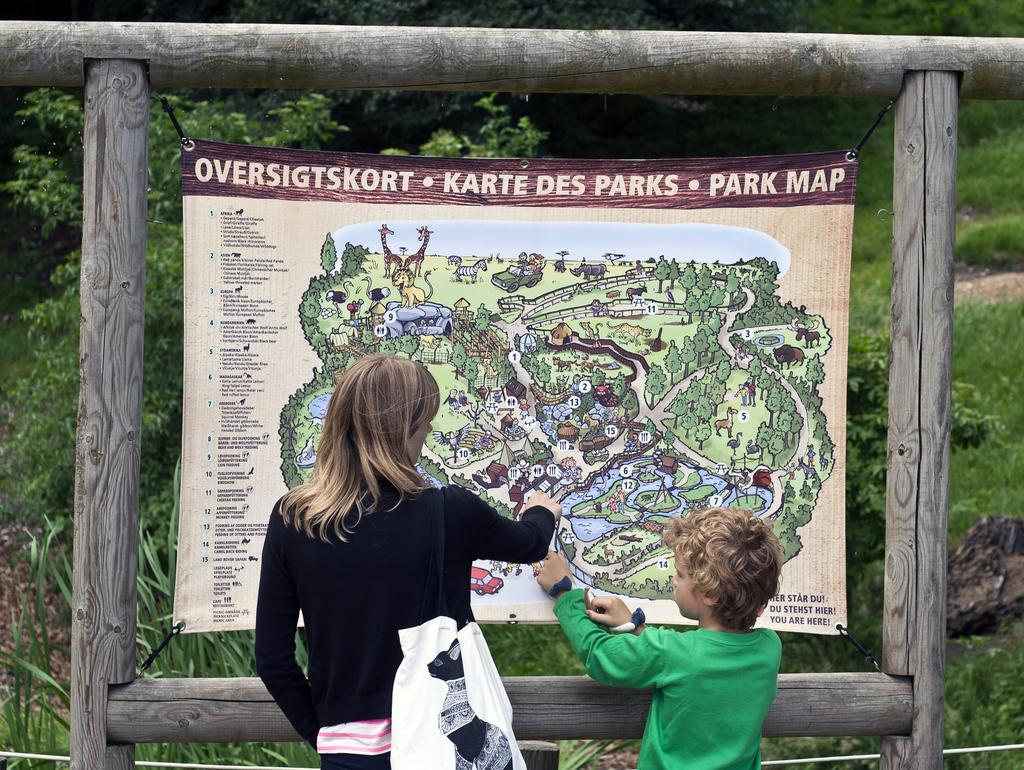In one or two sentences, can you explain what this image depicts? In this image I can see a woman is pointing the finger in the map. Beside her a boy is also pointing his hands in that map, he wore green color t-shirt. In the middle it is a wooden frame. Behind this there are trees. 